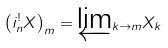Convert formula to latex. <formula><loc_0><loc_0><loc_500><loc_500>\left ( i _ { n } ^ { ! } X \right ) _ { m } = \underleftarrow { \lim } _ { k \rightarrow m } X _ { k }</formula> 